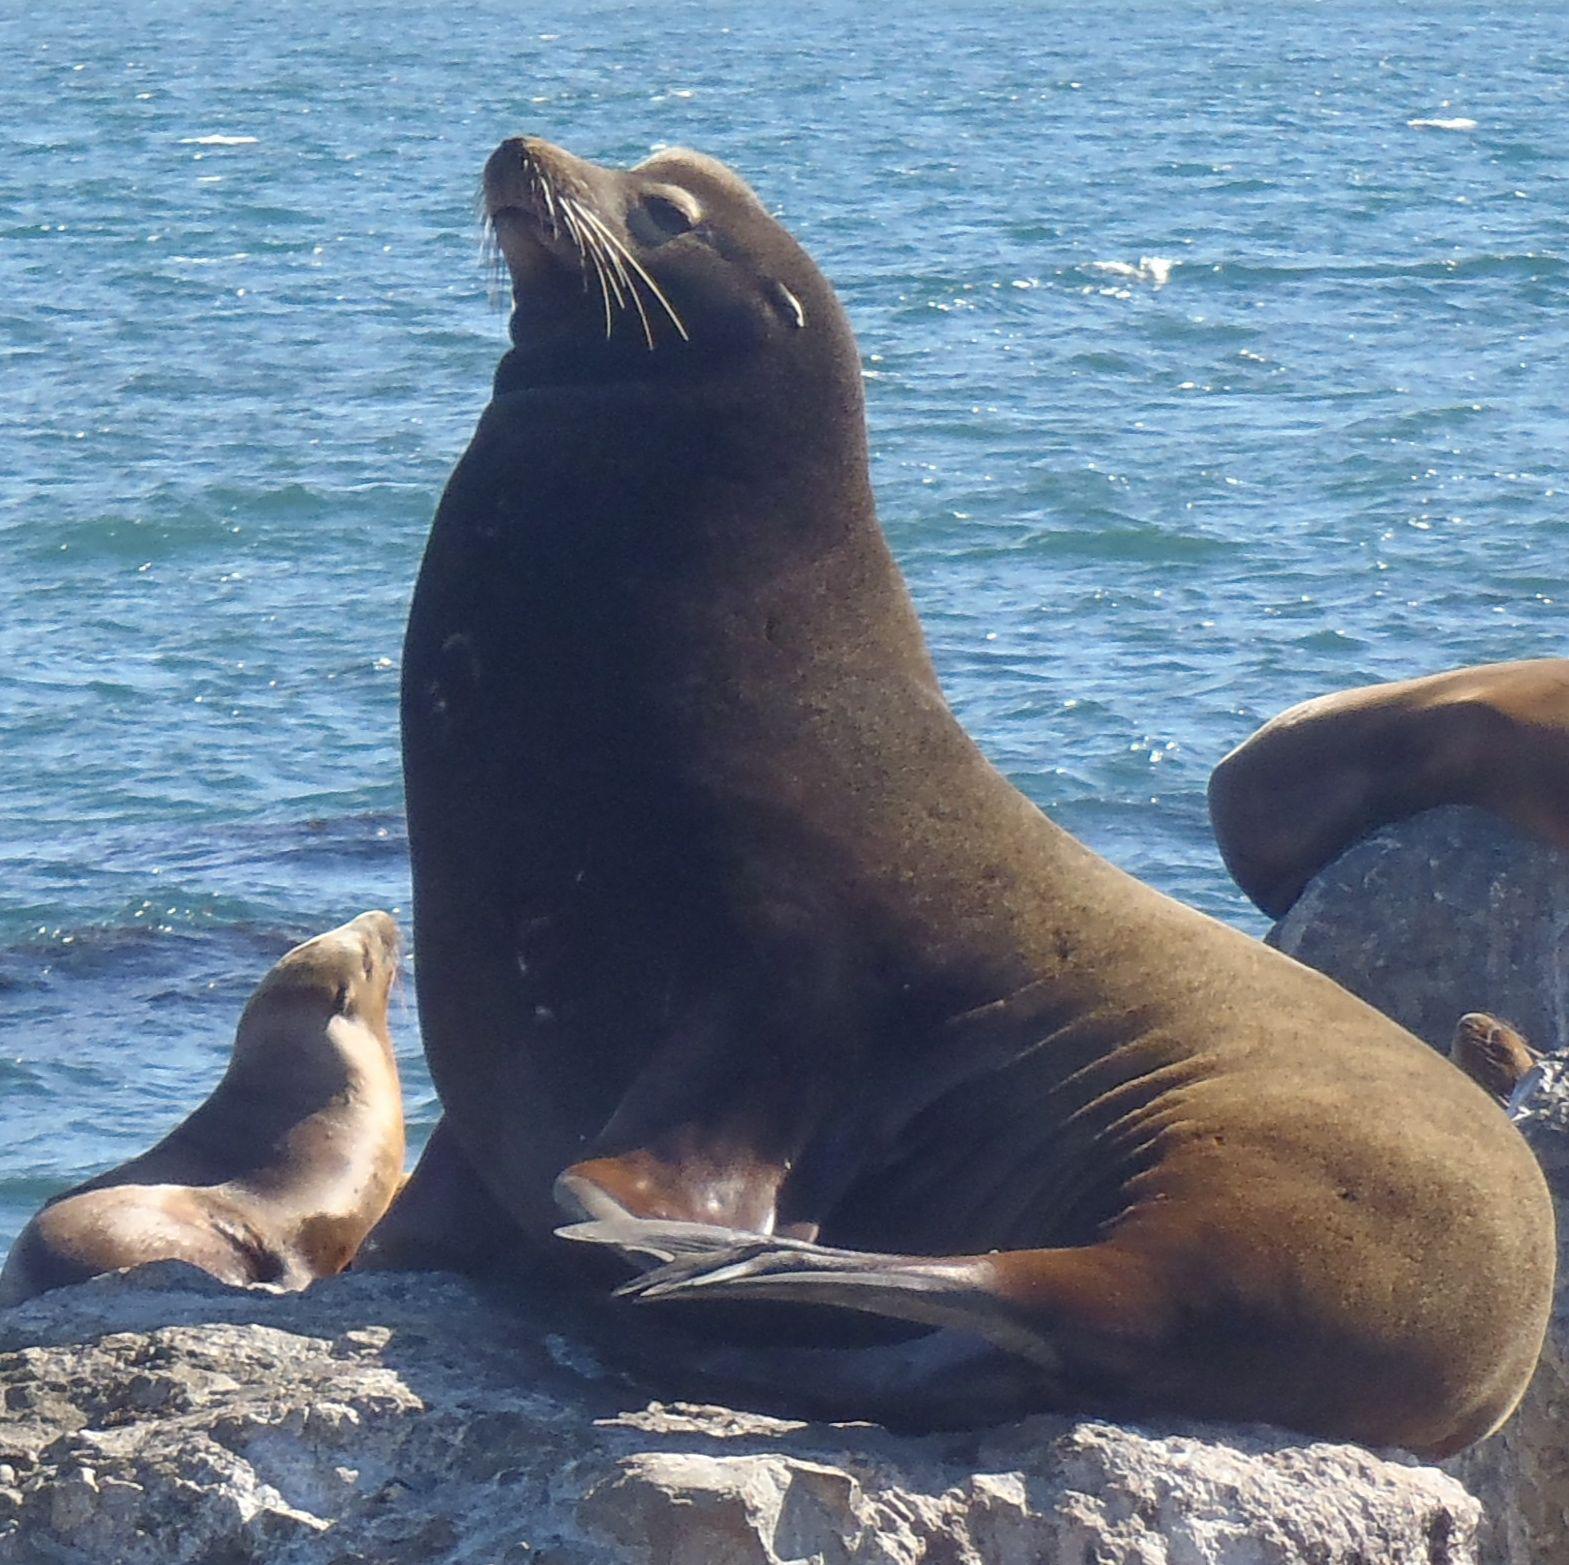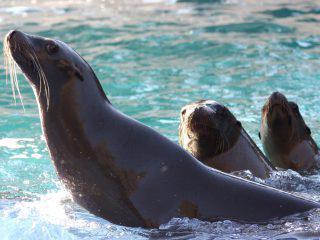The first image is the image on the left, the second image is the image on the right. For the images shown, is this caption "The right image contains exactly two seals." true? Answer yes or no. No. 